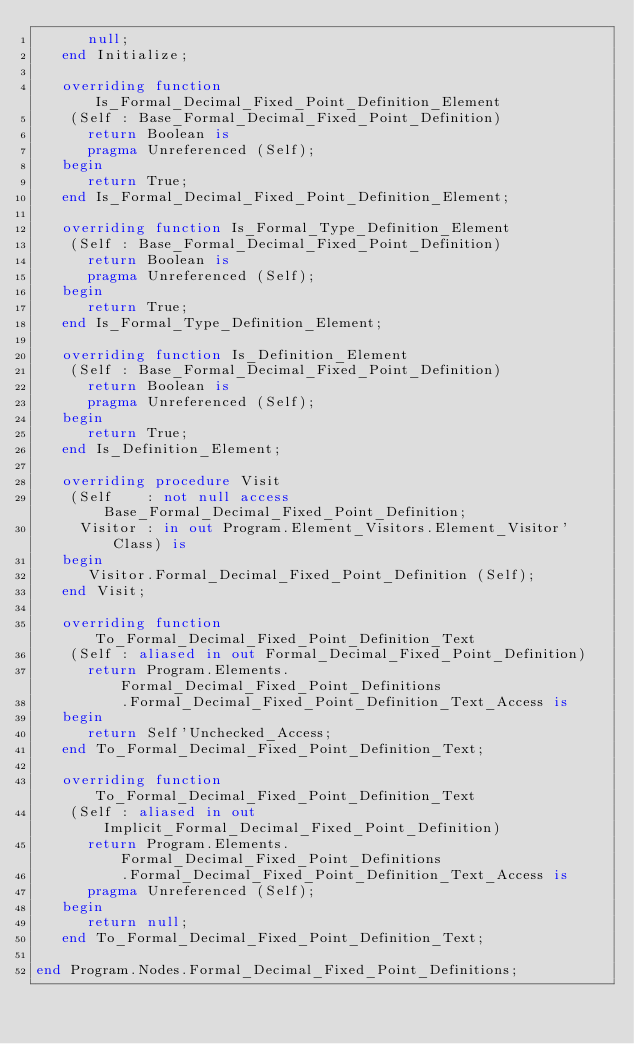<code> <loc_0><loc_0><loc_500><loc_500><_Ada_>      null;
   end Initialize;

   overriding function Is_Formal_Decimal_Fixed_Point_Definition_Element
    (Self : Base_Formal_Decimal_Fixed_Point_Definition)
      return Boolean is
      pragma Unreferenced (Self);
   begin
      return True;
   end Is_Formal_Decimal_Fixed_Point_Definition_Element;

   overriding function Is_Formal_Type_Definition_Element
    (Self : Base_Formal_Decimal_Fixed_Point_Definition)
      return Boolean is
      pragma Unreferenced (Self);
   begin
      return True;
   end Is_Formal_Type_Definition_Element;

   overriding function Is_Definition_Element
    (Self : Base_Formal_Decimal_Fixed_Point_Definition)
      return Boolean is
      pragma Unreferenced (Self);
   begin
      return True;
   end Is_Definition_Element;

   overriding procedure Visit
    (Self    : not null access Base_Formal_Decimal_Fixed_Point_Definition;
     Visitor : in out Program.Element_Visitors.Element_Visitor'Class) is
   begin
      Visitor.Formal_Decimal_Fixed_Point_Definition (Self);
   end Visit;

   overriding function To_Formal_Decimal_Fixed_Point_Definition_Text
    (Self : aliased in out Formal_Decimal_Fixed_Point_Definition)
      return Program.Elements.Formal_Decimal_Fixed_Point_Definitions
          .Formal_Decimal_Fixed_Point_Definition_Text_Access is
   begin
      return Self'Unchecked_Access;
   end To_Formal_Decimal_Fixed_Point_Definition_Text;

   overriding function To_Formal_Decimal_Fixed_Point_Definition_Text
    (Self : aliased in out Implicit_Formal_Decimal_Fixed_Point_Definition)
      return Program.Elements.Formal_Decimal_Fixed_Point_Definitions
          .Formal_Decimal_Fixed_Point_Definition_Text_Access is
      pragma Unreferenced (Self);
   begin
      return null;
   end To_Formal_Decimal_Fixed_Point_Definition_Text;

end Program.Nodes.Formal_Decimal_Fixed_Point_Definitions;
</code> 